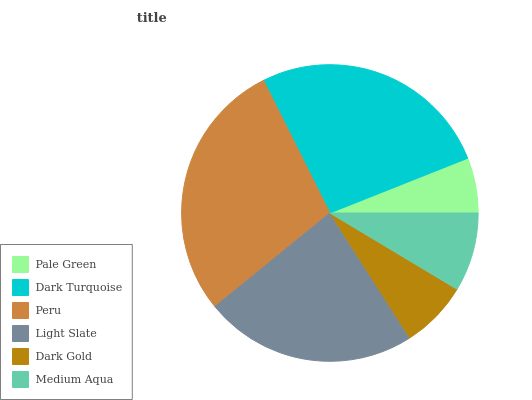Is Pale Green the minimum?
Answer yes or no. Yes. Is Peru the maximum?
Answer yes or no. Yes. Is Dark Turquoise the minimum?
Answer yes or no. No. Is Dark Turquoise the maximum?
Answer yes or no. No. Is Dark Turquoise greater than Pale Green?
Answer yes or no. Yes. Is Pale Green less than Dark Turquoise?
Answer yes or no. Yes. Is Pale Green greater than Dark Turquoise?
Answer yes or no. No. Is Dark Turquoise less than Pale Green?
Answer yes or no. No. Is Light Slate the high median?
Answer yes or no. Yes. Is Medium Aqua the low median?
Answer yes or no. Yes. Is Peru the high median?
Answer yes or no. No. Is Dark Turquoise the low median?
Answer yes or no. No. 